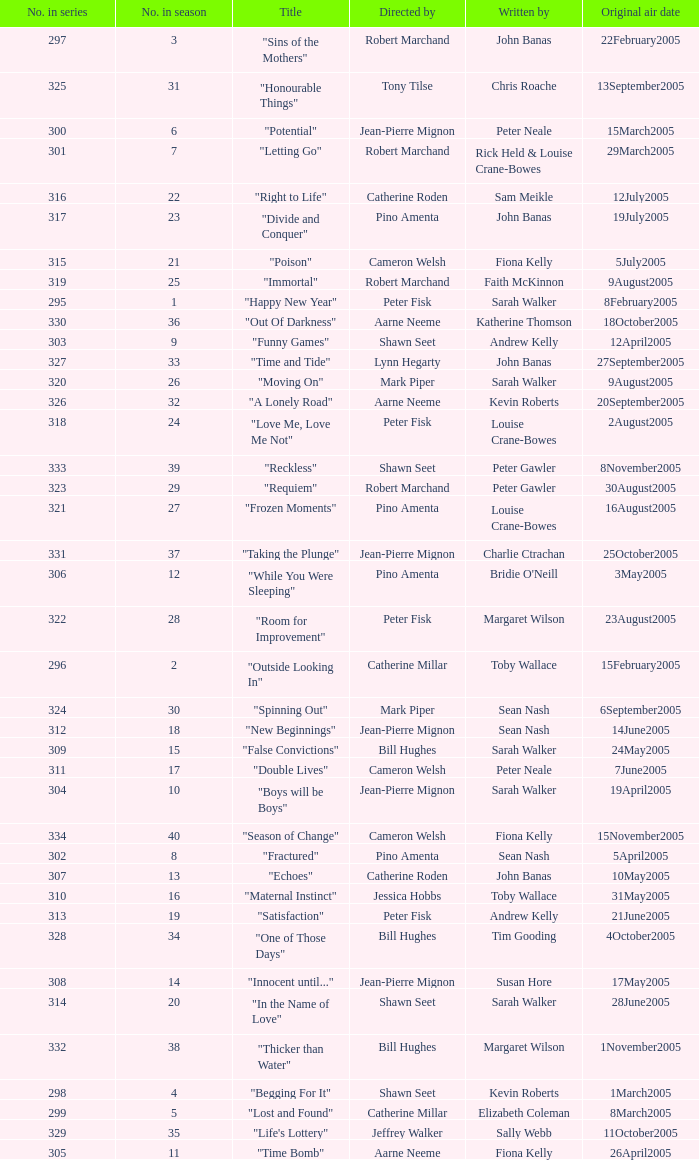Name the total number in the series written by john banas and directed by pino amenta 1.0. 